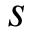Convert formula to latex. <formula><loc_0><loc_0><loc_500><loc_500>s</formula> 